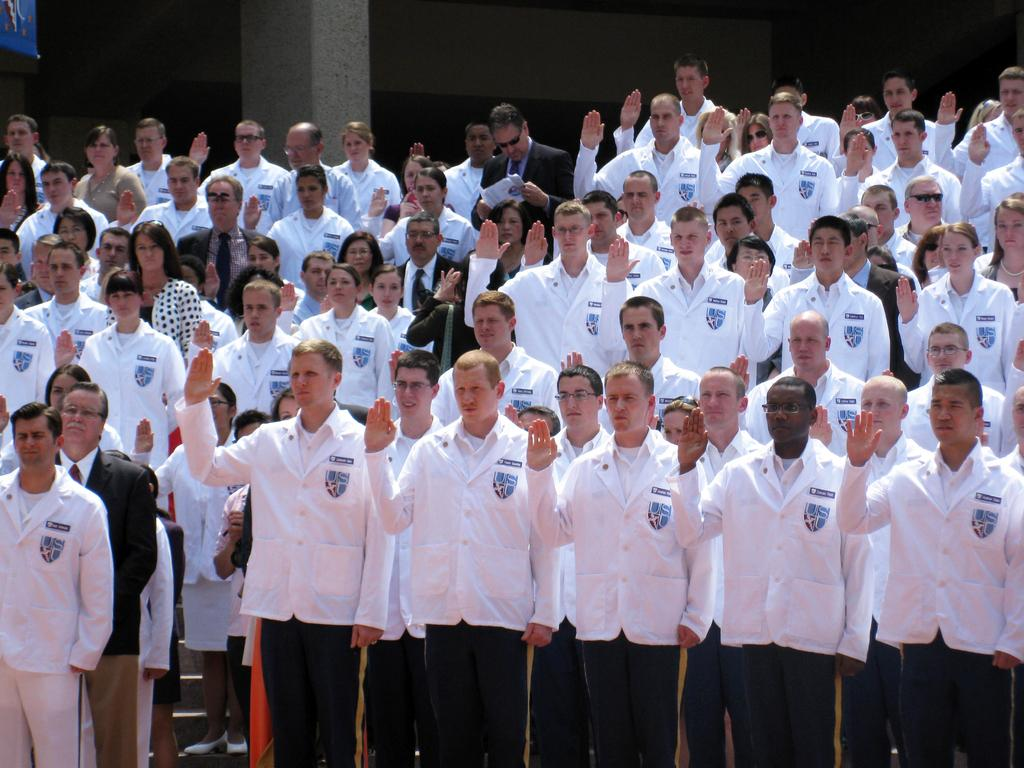What is happening in the image? There is a group of people standing in the image. What can be seen in the background of the image? There is a building in the background of the image. What architectural feature is present at the bottom of the image? There is a staircase at the bottom of the image. What is a common characteristic among some of the people in the group? There are people wearing white shirts in the group. Can you hear a whistle in the image? There is no mention of a whistle in the image, so it cannot be heard. 